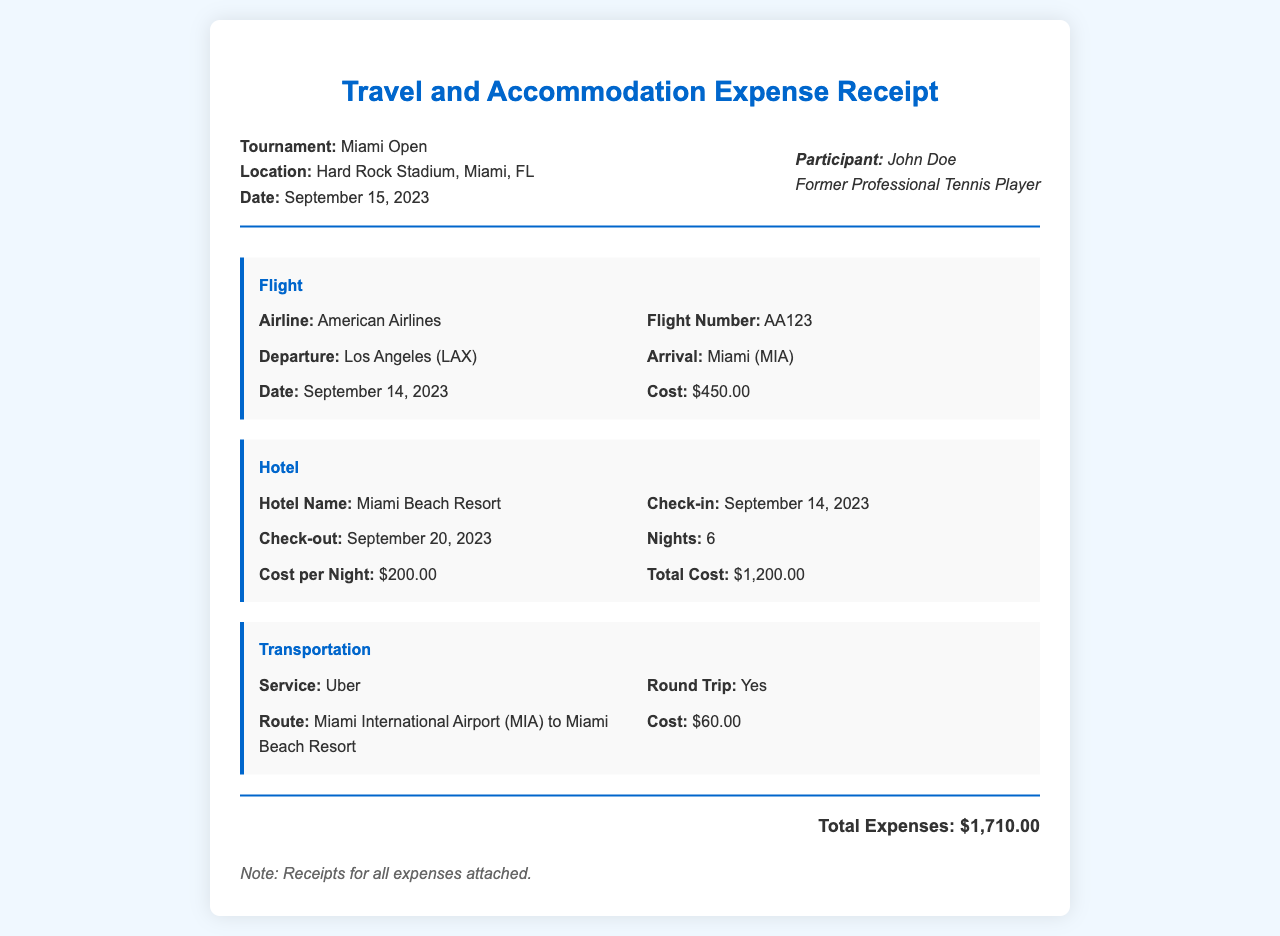What is the tournament name? The tournament name is listed at the top of the receipt, which is Miami Open.
Answer: Miami Open What is the total accommodation cost? The accommodation cost is detailed under the Hotel section, which shows a total cost of $1200.00.
Answer: $1200.00 What is the airline for the flight? The airline provider for the flight from Los Angeles to Miami is mentioned in the Flight section as American Airlines.
Answer: American Airlines What is the cost of transportation? The Transportation section states the cost for Uber service, which is $60.00.
Answer: $60.00 How many nights did the participant stay at the hotel? The number of nights is specified in the Hotel section as 6 nights.
Answer: 6 What is the flight number? The flight number is specified under the Flight section as AA123.
Answer: AA123 What is the check-in date for the hotel? The check-in date for the hotel is clearly mentioned as September 14, 2023.
Answer: September 14, 2023 What is the total expense amount? The total expenses are summed up at the bottom of the receipt, amounting to $1710.00.
Answer: $1710.00 Which city is the tournament held in? The city where the tournament takes place is referenced in the document as Miami, FL.
Answer: Miami, FL 